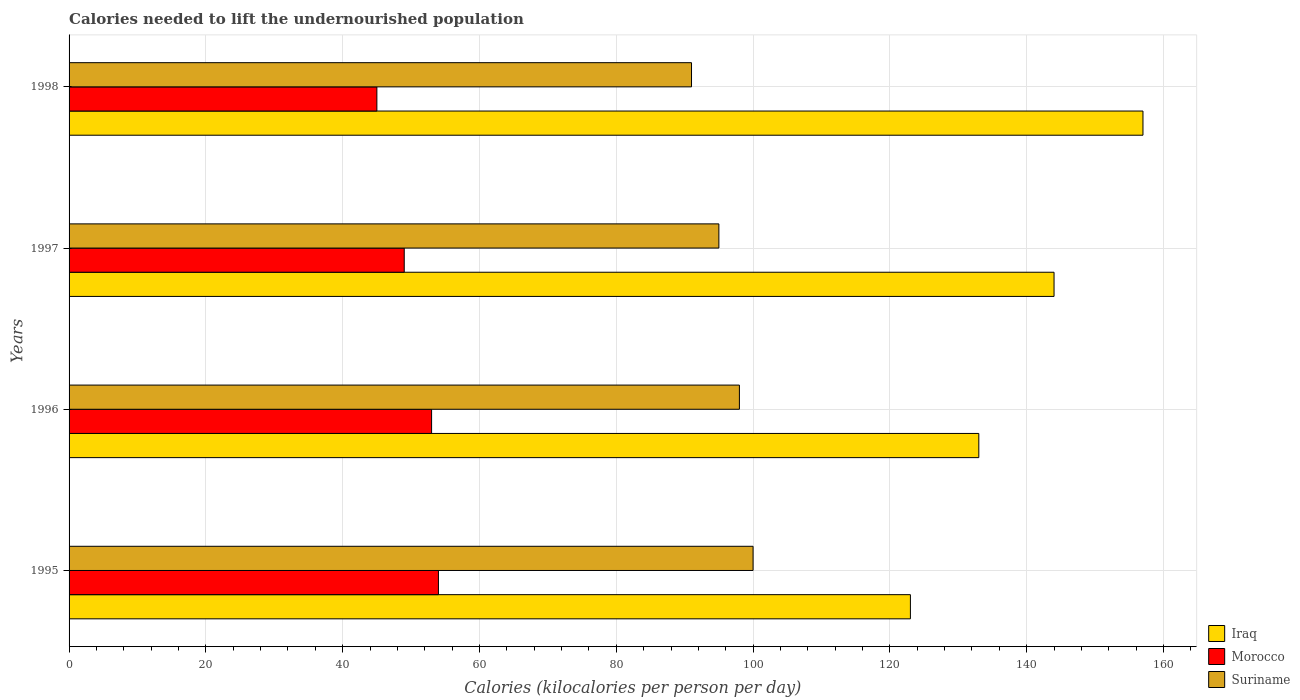How many groups of bars are there?
Keep it short and to the point. 4. Are the number of bars on each tick of the Y-axis equal?
Your answer should be very brief. Yes. What is the label of the 3rd group of bars from the top?
Offer a very short reply. 1996. What is the total calories needed to lift the undernourished population in Iraq in 1997?
Your answer should be very brief. 144. Across all years, what is the maximum total calories needed to lift the undernourished population in Suriname?
Give a very brief answer. 100. Across all years, what is the minimum total calories needed to lift the undernourished population in Morocco?
Offer a very short reply. 45. In which year was the total calories needed to lift the undernourished population in Suriname minimum?
Make the answer very short. 1998. What is the total total calories needed to lift the undernourished population in Morocco in the graph?
Your answer should be compact. 201. What is the difference between the total calories needed to lift the undernourished population in Suriname in 1995 and that in 1996?
Provide a succinct answer. 2. What is the difference between the total calories needed to lift the undernourished population in Suriname in 1996 and the total calories needed to lift the undernourished population in Iraq in 1997?
Provide a succinct answer. -46. What is the average total calories needed to lift the undernourished population in Suriname per year?
Make the answer very short. 96. In the year 1995, what is the difference between the total calories needed to lift the undernourished population in Suriname and total calories needed to lift the undernourished population in Morocco?
Make the answer very short. 46. What is the ratio of the total calories needed to lift the undernourished population in Morocco in 1995 to that in 1997?
Your answer should be compact. 1.1. Is the difference between the total calories needed to lift the undernourished population in Suriname in 1995 and 1997 greater than the difference between the total calories needed to lift the undernourished population in Morocco in 1995 and 1997?
Give a very brief answer. No. What is the difference between the highest and the lowest total calories needed to lift the undernourished population in Iraq?
Ensure brevity in your answer.  34. What does the 1st bar from the top in 1997 represents?
Provide a short and direct response. Suriname. What does the 2nd bar from the bottom in 1995 represents?
Offer a terse response. Morocco. How many bars are there?
Ensure brevity in your answer.  12. Are all the bars in the graph horizontal?
Make the answer very short. Yes. How many years are there in the graph?
Your response must be concise. 4. Are the values on the major ticks of X-axis written in scientific E-notation?
Ensure brevity in your answer.  No. What is the title of the graph?
Provide a short and direct response. Calories needed to lift the undernourished population. What is the label or title of the X-axis?
Offer a terse response. Calories (kilocalories per person per day). What is the label or title of the Y-axis?
Offer a terse response. Years. What is the Calories (kilocalories per person per day) of Iraq in 1995?
Keep it short and to the point. 123. What is the Calories (kilocalories per person per day) in Morocco in 1995?
Keep it short and to the point. 54. What is the Calories (kilocalories per person per day) in Suriname in 1995?
Your answer should be very brief. 100. What is the Calories (kilocalories per person per day) of Iraq in 1996?
Give a very brief answer. 133. What is the Calories (kilocalories per person per day) in Suriname in 1996?
Offer a very short reply. 98. What is the Calories (kilocalories per person per day) of Iraq in 1997?
Keep it short and to the point. 144. What is the Calories (kilocalories per person per day) of Suriname in 1997?
Keep it short and to the point. 95. What is the Calories (kilocalories per person per day) in Iraq in 1998?
Offer a very short reply. 157. What is the Calories (kilocalories per person per day) of Suriname in 1998?
Provide a short and direct response. 91. Across all years, what is the maximum Calories (kilocalories per person per day) of Iraq?
Provide a succinct answer. 157. Across all years, what is the maximum Calories (kilocalories per person per day) in Suriname?
Offer a very short reply. 100. Across all years, what is the minimum Calories (kilocalories per person per day) of Iraq?
Ensure brevity in your answer.  123. Across all years, what is the minimum Calories (kilocalories per person per day) of Morocco?
Provide a succinct answer. 45. Across all years, what is the minimum Calories (kilocalories per person per day) in Suriname?
Your response must be concise. 91. What is the total Calories (kilocalories per person per day) in Iraq in the graph?
Your answer should be compact. 557. What is the total Calories (kilocalories per person per day) in Morocco in the graph?
Give a very brief answer. 201. What is the total Calories (kilocalories per person per day) of Suriname in the graph?
Your answer should be very brief. 384. What is the difference between the Calories (kilocalories per person per day) of Morocco in 1995 and that in 1996?
Make the answer very short. 1. What is the difference between the Calories (kilocalories per person per day) of Iraq in 1995 and that in 1997?
Your answer should be very brief. -21. What is the difference between the Calories (kilocalories per person per day) of Morocco in 1995 and that in 1997?
Provide a short and direct response. 5. What is the difference between the Calories (kilocalories per person per day) in Iraq in 1995 and that in 1998?
Keep it short and to the point. -34. What is the difference between the Calories (kilocalories per person per day) in Morocco in 1996 and that in 1998?
Your response must be concise. 8. What is the difference between the Calories (kilocalories per person per day) in Suriname in 1996 and that in 1998?
Your response must be concise. 7. What is the difference between the Calories (kilocalories per person per day) of Morocco in 1997 and that in 1998?
Make the answer very short. 4. What is the difference between the Calories (kilocalories per person per day) of Suriname in 1997 and that in 1998?
Keep it short and to the point. 4. What is the difference between the Calories (kilocalories per person per day) of Iraq in 1995 and the Calories (kilocalories per person per day) of Morocco in 1996?
Make the answer very short. 70. What is the difference between the Calories (kilocalories per person per day) of Iraq in 1995 and the Calories (kilocalories per person per day) of Suriname in 1996?
Your answer should be compact. 25. What is the difference between the Calories (kilocalories per person per day) of Morocco in 1995 and the Calories (kilocalories per person per day) of Suriname in 1996?
Provide a succinct answer. -44. What is the difference between the Calories (kilocalories per person per day) of Morocco in 1995 and the Calories (kilocalories per person per day) of Suriname in 1997?
Make the answer very short. -41. What is the difference between the Calories (kilocalories per person per day) in Morocco in 1995 and the Calories (kilocalories per person per day) in Suriname in 1998?
Your response must be concise. -37. What is the difference between the Calories (kilocalories per person per day) of Morocco in 1996 and the Calories (kilocalories per person per day) of Suriname in 1997?
Your answer should be compact. -42. What is the difference between the Calories (kilocalories per person per day) of Iraq in 1996 and the Calories (kilocalories per person per day) of Suriname in 1998?
Offer a very short reply. 42. What is the difference between the Calories (kilocalories per person per day) of Morocco in 1996 and the Calories (kilocalories per person per day) of Suriname in 1998?
Provide a succinct answer. -38. What is the difference between the Calories (kilocalories per person per day) of Morocco in 1997 and the Calories (kilocalories per person per day) of Suriname in 1998?
Ensure brevity in your answer.  -42. What is the average Calories (kilocalories per person per day) in Iraq per year?
Offer a very short reply. 139.25. What is the average Calories (kilocalories per person per day) of Morocco per year?
Make the answer very short. 50.25. What is the average Calories (kilocalories per person per day) in Suriname per year?
Ensure brevity in your answer.  96. In the year 1995, what is the difference between the Calories (kilocalories per person per day) of Morocco and Calories (kilocalories per person per day) of Suriname?
Provide a short and direct response. -46. In the year 1996, what is the difference between the Calories (kilocalories per person per day) of Iraq and Calories (kilocalories per person per day) of Morocco?
Keep it short and to the point. 80. In the year 1996, what is the difference between the Calories (kilocalories per person per day) in Morocco and Calories (kilocalories per person per day) in Suriname?
Offer a terse response. -45. In the year 1997, what is the difference between the Calories (kilocalories per person per day) of Iraq and Calories (kilocalories per person per day) of Morocco?
Make the answer very short. 95. In the year 1997, what is the difference between the Calories (kilocalories per person per day) in Morocco and Calories (kilocalories per person per day) in Suriname?
Keep it short and to the point. -46. In the year 1998, what is the difference between the Calories (kilocalories per person per day) in Iraq and Calories (kilocalories per person per day) in Morocco?
Your answer should be very brief. 112. In the year 1998, what is the difference between the Calories (kilocalories per person per day) of Morocco and Calories (kilocalories per person per day) of Suriname?
Offer a terse response. -46. What is the ratio of the Calories (kilocalories per person per day) of Iraq in 1995 to that in 1996?
Your answer should be compact. 0.92. What is the ratio of the Calories (kilocalories per person per day) of Morocco in 1995 to that in 1996?
Your response must be concise. 1.02. What is the ratio of the Calories (kilocalories per person per day) in Suriname in 1995 to that in 1996?
Provide a short and direct response. 1.02. What is the ratio of the Calories (kilocalories per person per day) of Iraq in 1995 to that in 1997?
Ensure brevity in your answer.  0.85. What is the ratio of the Calories (kilocalories per person per day) in Morocco in 1995 to that in 1997?
Provide a short and direct response. 1.1. What is the ratio of the Calories (kilocalories per person per day) of Suriname in 1995 to that in 1997?
Your response must be concise. 1.05. What is the ratio of the Calories (kilocalories per person per day) of Iraq in 1995 to that in 1998?
Offer a very short reply. 0.78. What is the ratio of the Calories (kilocalories per person per day) of Suriname in 1995 to that in 1998?
Give a very brief answer. 1.1. What is the ratio of the Calories (kilocalories per person per day) in Iraq in 1996 to that in 1997?
Your answer should be compact. 0.92. What is the ratio of the Calories (kilocalories per person per day) in Morocco in 1996 to that in 1997?
Provide a succinct answer. 1.08. What is the ratio of the Calories (kilocalories per person per day) of Suriname in 1996 to that in 1997?
Give a very brief answer. 1.03. What is the ratio of the Calories (kilocalories per person per day) in Iraq in 1996 to that in 1998?
Provide a short and direct response. 0.85. What is the ratio of the Calories (kilocalories per person per day) of Morocco in 1996 to that in 1998?
Make the answer very short. 1.18. What is the ratio of the Calories (kilocalories per person per day) of Iraq in 1997 to that in 1998?
Offer a very short reply. 0.92. What is the ratio of the Calories (kilocalories per person per day) of Morocco in 1997 to that in 1998?
Give a very brief answer. 1.09. What is the ratio of the Calories (kilocalories per person per day) in Suriname in 1997 to that in 1998?
Your answer should be very brief. 1.04. What is the difference between the highest and the lowest Calories (kilocalories per person per day) in Iraq?
Give a very brief answer. 34. What is the difference between the highest and the lowest Calories (kilocalories per person per day) of Morocco?
Your response must be concise. 9. What is the difference between the highest and the lowest Calories (kilocalories per person per day) of Suriname?
Keep it short and to the point. 9. 